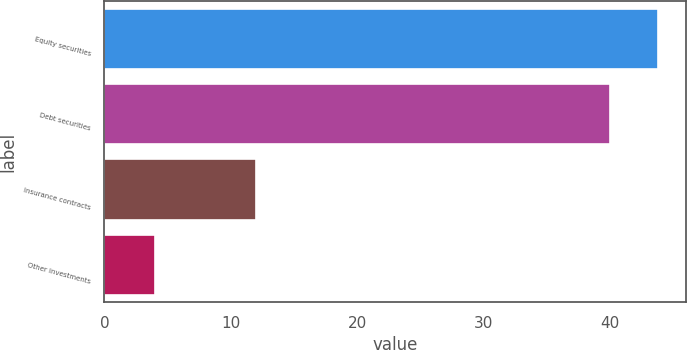<chart> <loc_0><loc_0><loc_500><loc_500><bar_chart><fcel>Equity securities<fcel>Debt securities<fcel>Insurance contracts<fcel>Other investments<nl><fcel>43.8<fcel>40<fcel>12<fcel>4<nl></chart> 